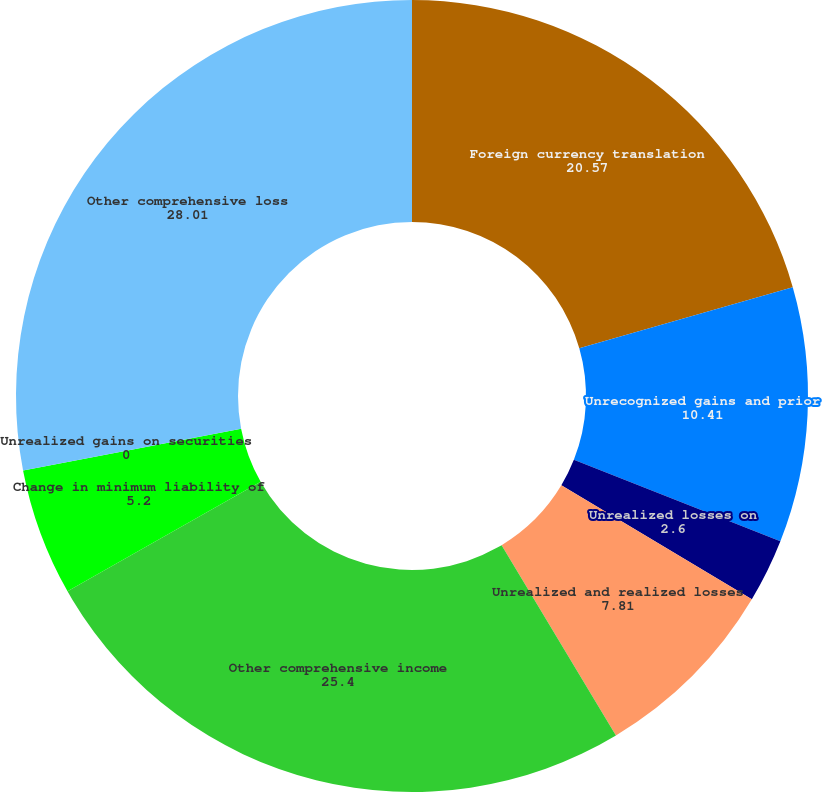Convert chart to OTSL. <chart><loc_0><loc_0><loc_500><loc_500><pie_chart><fcel>Foreign currency translation<fcel>Unrecognized gains and prior<fcel>Unrealized losses on<fcel>Unrealized and realized losses<fcel>Other comprehensive income<fcel>Change in minimum liability of<fcel>Unrealized gains on securities<fcel>Other comprehensive loss<nl><fcel>20.57%<fcel>10.41%<fcel>2.6%<fcel>7.81%<fcel>25.4%<fcel>5.2%<fcel>0.0%<fcel>28.01%<nl></chart> 